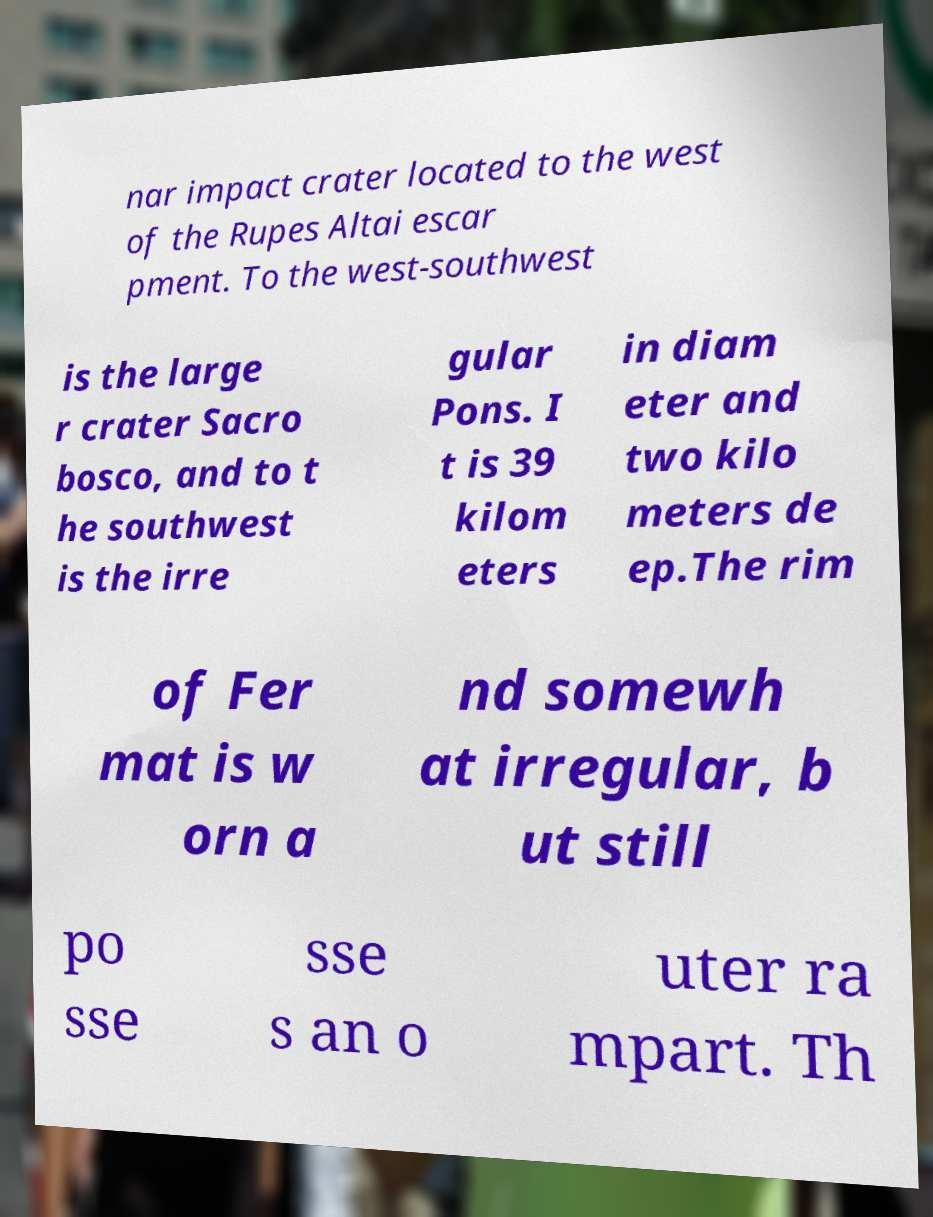Please read and relay the text visible in this image. What does it say? nar impact crater located to the west of the Rupes Altai escar pment. To the west-southwest is the large r crater Sacro bosco, and to t he southwest is the irre gular Pons. I t is 39 kilom eters in diam eter and two kilo meters de ep.The rim of Fer mat is w orn a nd somewh at irregular, b ut still po sse sse s an o uter ra mpart. Th 